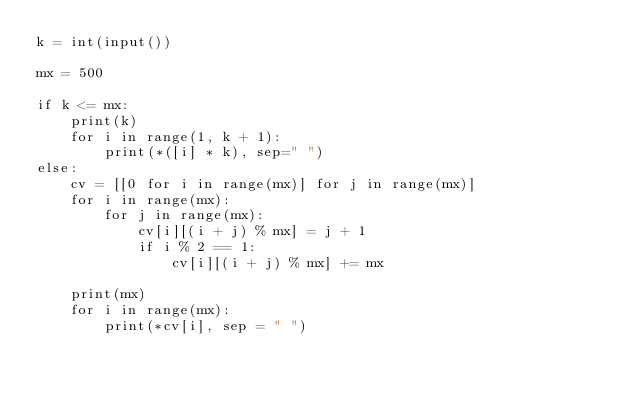Convert code to text. <code><loc_0><loc_0><loc_500><loc_500><_Python_>k = int(input())

mx = 500

if k <= mx:
    print(k)
    for i in range(1, k + 1):
        print(*([i] * k), sep=" ")
else:
    cv = [[0 for i in range(mx)] for j in range(mx)]
    for i in range(mx):
        for j in range(mx):
            cv[i][(i + j) % mx] = j + 1
            if i % 2 == 1:
                cv[i][(i + j) % mx] += mx
    
    print(mx)
    for i in range(mx):
        print(*cv[i], sep = " ")</code> 